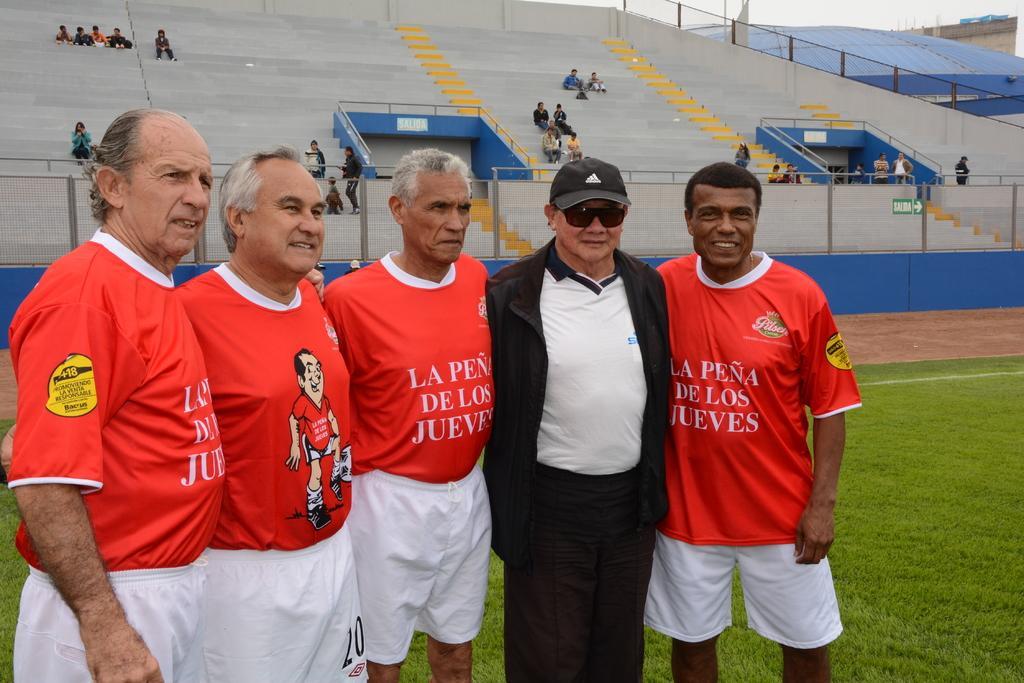In one or two sentences, can you explain what this image depicts? In the picture we can see five people standing. We can also there is grass. In the background we can see stadium, people and building. 